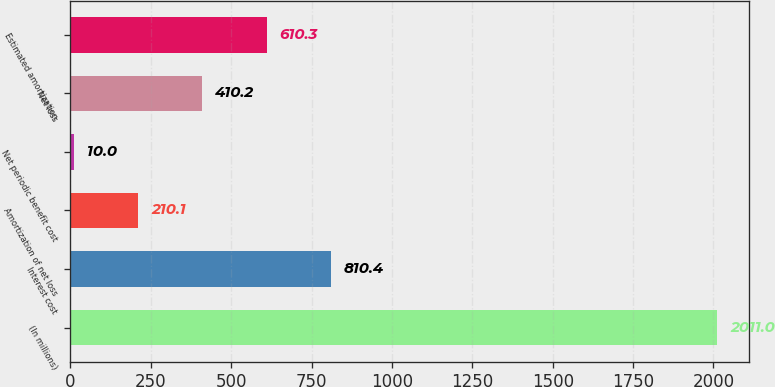<chart> <loc_0><loc_0><loc_500><loc_500><bar_chart><fcel>(In millions)<fcel>Interest cost<fcel>Amortization of net loss<fcel>Net periodic benefit cost<fcel>Net loss<fcel>Estimated amortization<nl><fcel>2011<fcel>810.4<fcel>210.1<fcel>10<fcel>410.2<fcel>610.3<nl></chart> 